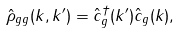Convert formula to latex. <formula><loc_0><loc_0><loc_500><loc_500>\hat { \rho } _ { g g } ( k , k ^ { \prime } ) = \hat { c } ^ { \dag } _ { g } ( k ^ { \prime } ) \hat { c } _ { g } ( k ) ,</formula> 